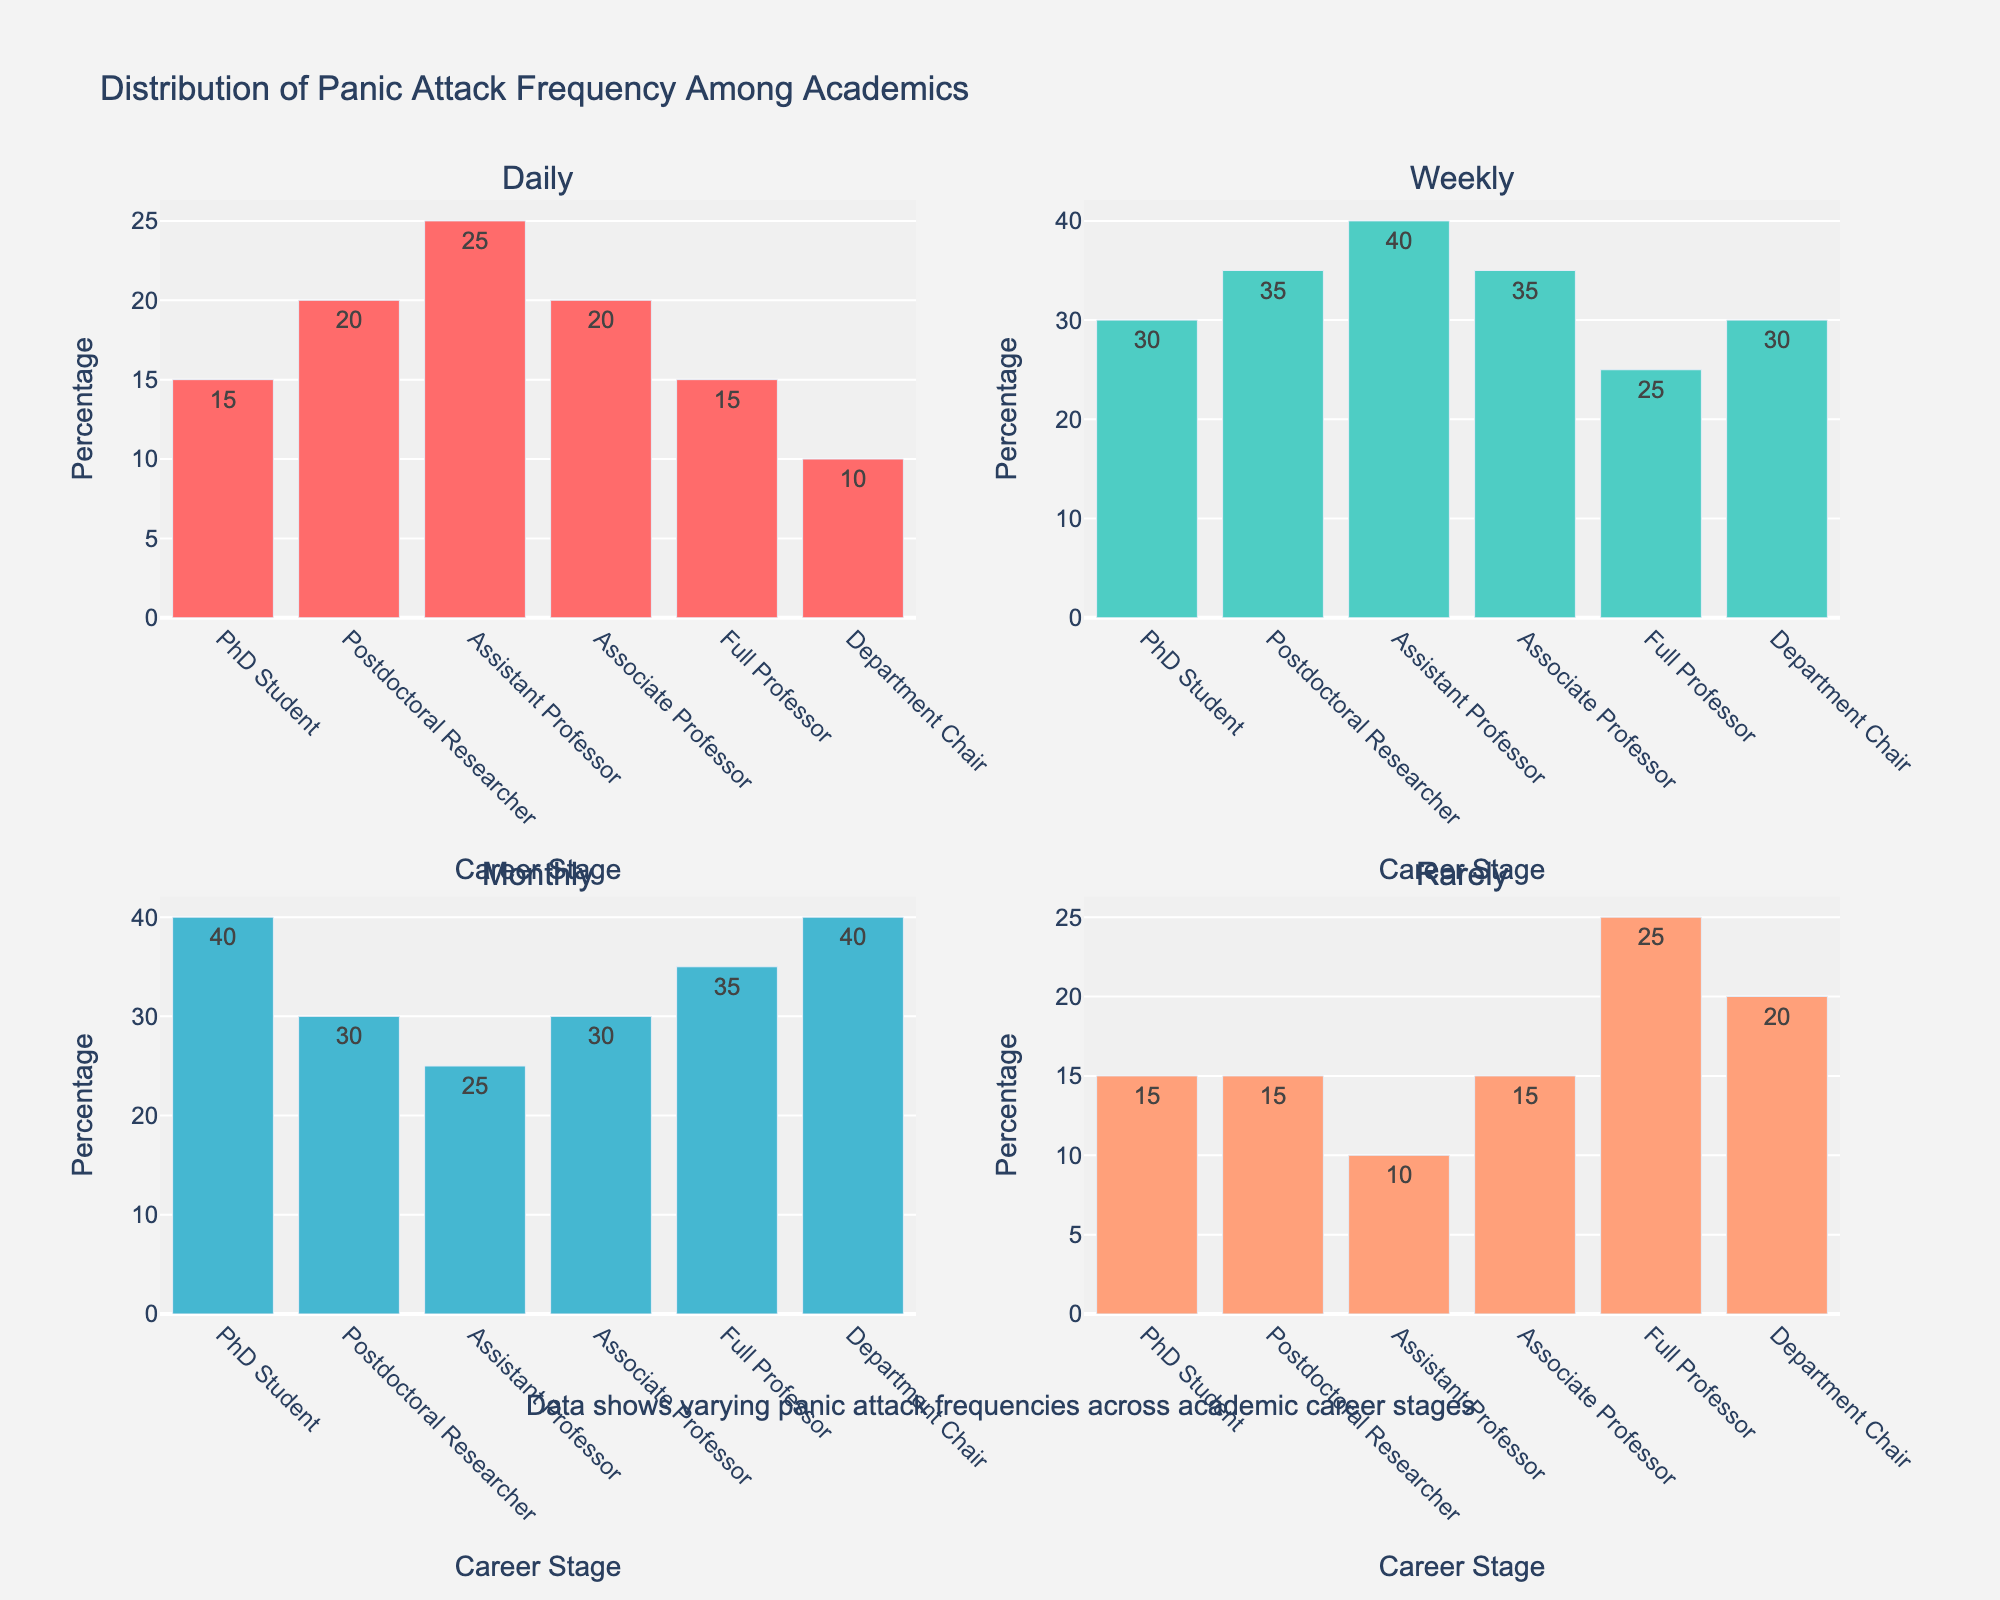what is the title of the subplot? The title is provided at the center-top of the figure, which states what the plot represents in a concise manner.
Answer: Distribution of Panic Attack Frequency Among Academics Which career stage shows the highest percentage of daily panic attacks? By looking at the 'Daily' subplot, identify the bar that reaches the highest value among all career stages. Here, the Assistant Professor stage has the highest bar.
Answer: Assistant Professor What is the average percentage of monthly panic attacks across all career stages? Average can be calculated by summing the percentages of monthly panic attacks for each career stage and dividing by the number of career stages. Sum: 40+30+25+30+35+40 = 200. Divide by 6: 200/6 ≈ 33.33
Answer: Approximately 33.33 Is there any career stage where the percentage of rarely occurring panic attacks is equal to the percentage of daily panic attacks? Compare the 'Daily' and 'Rarely' bars for each career stage. 'PhD Student' has equal percentages (15% for both daily and rarely).
Answer: PhD Student Which frequency of panic attacks has the most consistent percentages across all career stages, judging by the range of values? To determine consistency, check for the smallest range (difference between max and min values) for each frequency. 'Daily' ranges from 10 to 25 (15), 'Weekly' from 25 to 40 (15), 'Monthly' from 25 to 40 (15), and 'Rarely' from 10 to 25 (15). All have the same range, so let's choose daily panic attacks.
Answer: Daily What is the exact percentage difference between weekly panic attacks for a Full Professor and an Assistant Professor? Identify the heights of the bars for the 'Weekly' frequency for both career stages, then subtract the smaller value from the larger one: 40% (Assistant Professor) - 25% (Full Professor) = 15%
Answer: 15% Which career stage has the highest overall combined percentage in the daily and weekly categories? Sum the percentages of daily and weekly panic attacks for each career stage and identify the highest sum. Assistant Professor: 25+40=65, which is the highest.
Answer: Assistant Professor What is the range of panic attack percentages in the "Rarely" category? Find the maximum and minimum percentages in the "Rarely" subplot and subtract the smallest value from the largest. The range is 25 (Full Professor) - 10 (Assistant Professor) = 15.
Answer: 15 For which career stage is the percentage of monthly panic attacks exactly equal to the percentage of daily panic attacks for Postdoctoral Researchers? Check the 'Monthly' percentages for each career stage and see which one matches the 'Daily' percentage for Postdoctoral Researchers (20%). The corresponding stage is 'Daily' for the PhD Student.
Answer: PhD Student 